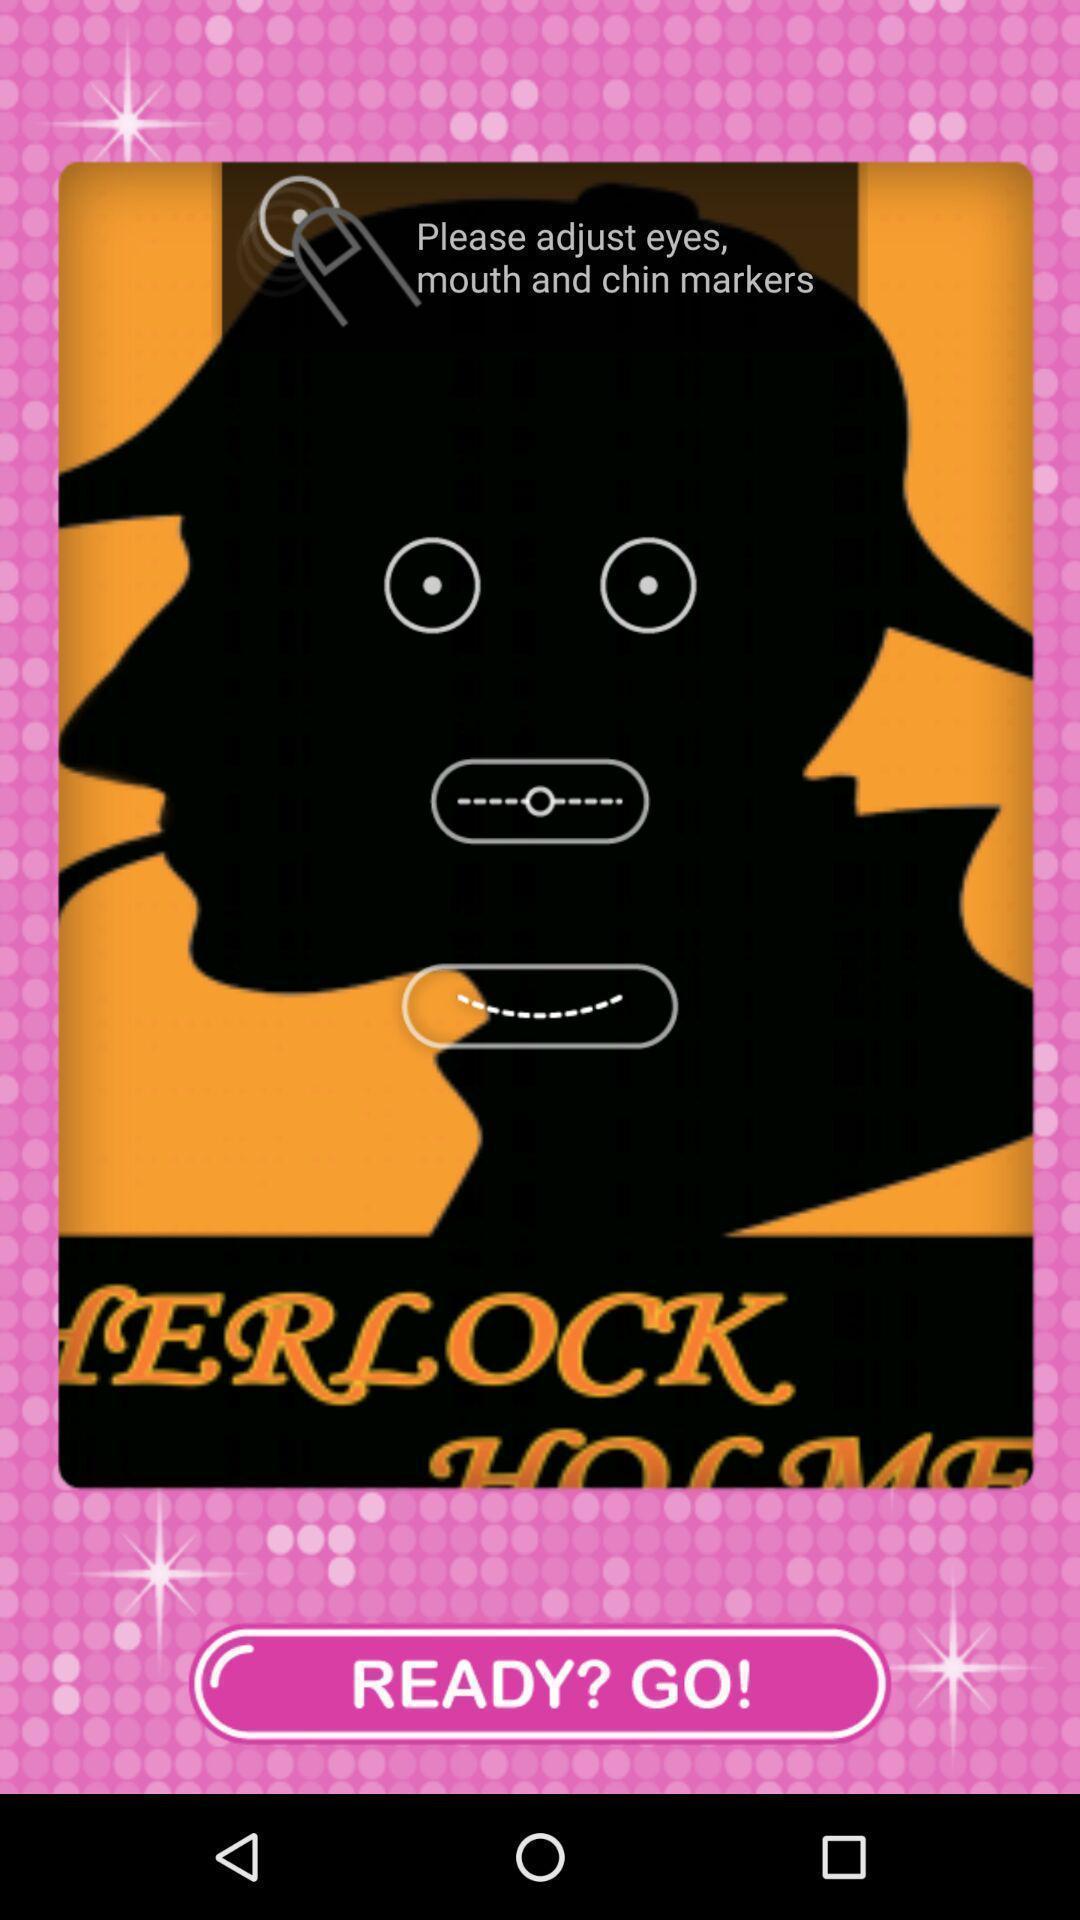Give me a summary of this screen capture. Welcome page. 